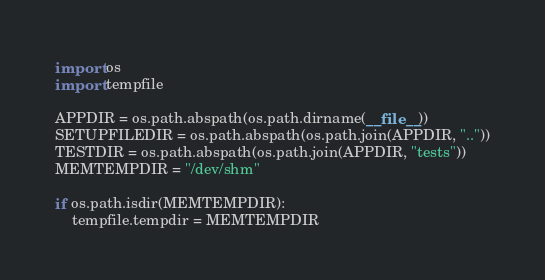Convert code to text. <code><loc_0><loc_0><loc_500><loc_500><_Python_>import os
import tempfile

APPDIR = os.path.abspath(os.path.dirname(__file__))
SETUPFILEDIR = os.path.abspath(os.path.join(APPDIR, ".."))
TESTDIR = os.path.abspath(os.path.join(APPDIR, "tests"))
MEMTEMPDIR = "/dev/shm"

if os.path.isdir(MEMTEMPDIR):
    tempfile.tempdir = MEMTEMPDIR
</code> 